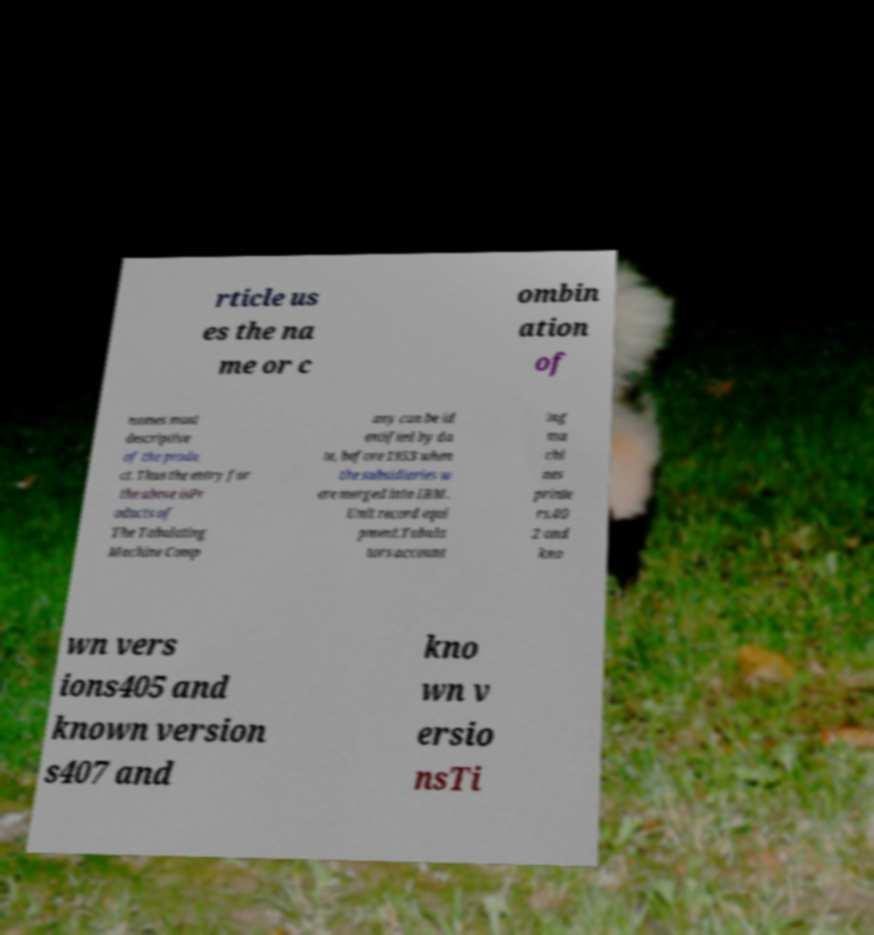I need the written content from this picture converted into text. Can you do that? rticle us es the na me or c ombin ation of names most descriptive of the produ ct. Thus the entry for the above isPr oducts of The Tabulating Machine Comp any can be id entified by da te, before 1933 when the subsidiaries w ere merged into IBM. Unit record equi pment.Tabula tors account ing ma chi nes printe rs.40 2 and kno wn vers ions405 and known version s407 and kno wn v ersio nsTi 